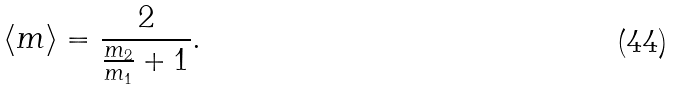Convert formula to latex. <formula><loc_0><loc_0><loc_500><loc_500>\langle m \rangle = \frac { 2 } { \frac { m _ { 2 } } { m _ { 1 } } + 1 } .</formula> 